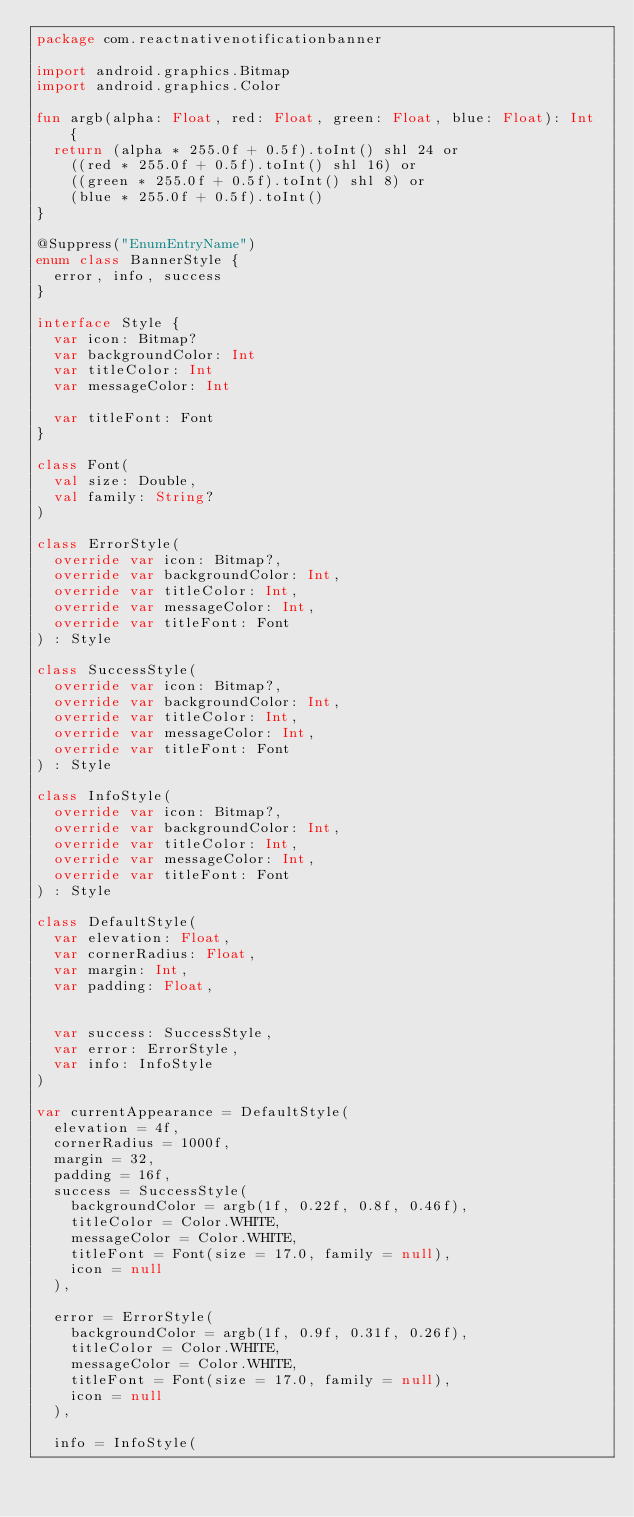Convert code to text. <code><loc_0><loc_0><loc_500><loc_500><_Kotlin_>package com.reactnativenotificationbanner

import android.graphics.Bitmap
import android.graphics.Color

fun argb(alpha: Float, red: Float, green: Float, blue: Float): Int {
  return (alpha * 255.0f + 0.5f).toInt() shl 24 or
    ((red * 255.0f + 0.5f).toInt() shl 16) or
    ((green * 255.0f + 0.5f).toInt() shl 8) or
    (blue * 255.0f + 0.5f).toInt()
}

@Suppress("EnumEntryName")
enum class BannerStyle {
  error, info, success
}

interface Style {
  var icon: Bitmap?
  var backgroundColor: Int
  var titleColor: Int
  var messageColor: Int

  var titleFont: Font
}

class Font(
  val size: Double,
  val family: String?
)

class ErrorStyle(
  override var icon: Bitmap?,
  override var backgroundColor: Int,
  override var titleColor: Int,
  override var messageColor: Int,
  override var titleFont: Font
) : Style

class SuccessStyle(
  override var icon: Bitmap?,
  override var backgroundColor: Int,
  override var titleColor: Int,
  override var messageColor: Int,
  override var titleFont: Font
) : Style

class InfoStyle(
  override var icon: Bitmap?,
  override var backgroundColor: Int,
  override var titleColor: Int,
  override var messageColor: Int,
  override var titleFont: Font
) : Style

class DefaultStyle(
  var elevation: Float,
  var cornerRadius: Float,
  var margin: Int,
  var padding: Float,


  var success: SuccessStyle,
  var error: ErrorStyle,
  var info: InfoStyle
)

var currentAppearance = DefaultStyle(
  elevation = 4f,
  cornerRadius = 1000f,
  margin = 32,
  padding = 16f,
  success = SuccessStyle(
    backgroundColor = argb(1f, 0.22f, 0.8f, 0.46f),
    titleColor = Color.WHITE,
    messageColor = Color.WHITE,
    titleFont = Font(size = 17.0, family = null),
    icon = null
  ),

  error = ErrorStyle(
    backgroundColor = argb(1f, 0.9f, 0.31f, 0.26f),
    titleColor = Color.WHITE,
    messageColor = Color.WHITE,
    titleFont = Font(size = 17.0, family = null),
    icon = null
  ),

  info = InfoStyle(</code> 